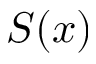Convert formula to latex. <formula><loc_0><loc_0><loc_500><loc_500>S ( x )</formula> 